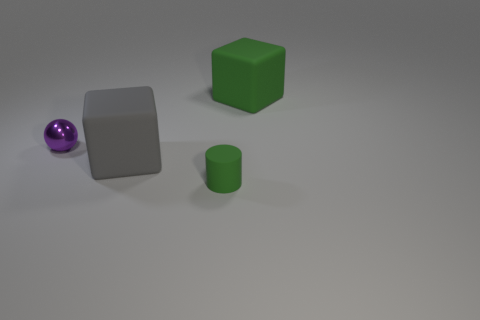Is there anything else that is the same material as the purple thing?
Offer a terse response. No. Is the rubber cylinder the same size as the sphere?
Make the answer very short. Yes. What size is the object that is both behind the gray object and on the left side of the green matte cylinder?
Offer a very short reply. Small. What number of rubber objects are purple objects or small yellow cubes?
Make the answer very short. 0. Are there more large gray rubber blocks to the left of the tiny purple sphere than gray matte spheres?
Offer a very short reply. No. What is the big cube on the left side of the small green cylinder made of?
Make the answer very short. Rubber. What number of green things have the same material as the big gray cube?
Provide a succinct answer. 2. What shape is the object that is in front of the metal object and on the left side of the tiny green matte object?
Provide a succinct answer. Cube. What number of things are either big matte things that are behind the large gray object or big matte objects that are to the right of the green cylinder?
Offer a terse response. 1. Are there an equal number of large gray matte cubes that are on the left side of the tiny green thing and large matte objects that are in front of the small purple thing?
Provide a short and direct response. Yes. 